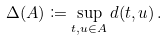Convert formula to latex. <formula><loc_0><loc_0><loc_500><loc_500>\Delta ( A ) \coloneqq \sup _ { t , u \in A } d ( t , u ) \, .</formula> 